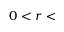<formula> <loc_0><loc_0><loc_500><loc_500>0 < r <</formula> 